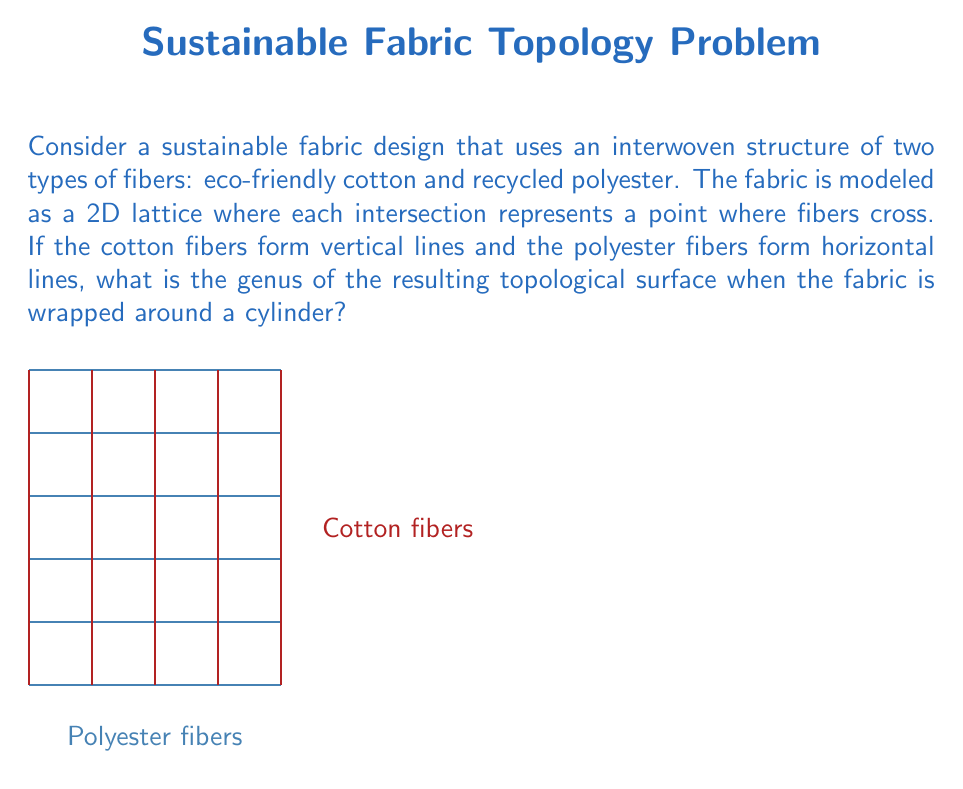Help me with this question. To determine the genus of the resulting topological surface, we need to follow these steps:

1) First, let's understand what happens when we wrap the fabric around a cylinder:
   - The vertical edges (cotton fibers) connect to form closed loops around the cylinder.
   - The horizontal edges (polyester fibers) connect to themselves, forming circles around the cylinder.

2) The resulting structure is a torus-like surface with multiple holes.

3) To calculate the genus, we need to count the number of holes in the surface. This is equal to the number of "cells" in our lattice before wrapping.

4) The number of cells in a lattice is given by:
   $$ \text{Number of cells} = (\text{Number of vertical lines} - 1) \times (\text{Number of horizontal lines} - 1) $$

5) In our case, let's assume we have $n$ vertical lines (cotton fibers) and $m$ horizontal lines (polyester fibers).

6) Therefore, the number of cells, which is equal to the genus of our surface, is:
   $$ g = (n-1)(m-1) $$

7) For example, if we have 6 vertical lines and 5 horizontal lines:
   $$ g = (6-1)(5-1) = 5 \times 4 = 20 $$

This means the resulting surface would have a genus of 20, equivalent to a surface with 20 holes.
Answer: $g = (n-1)(m-1)$ 